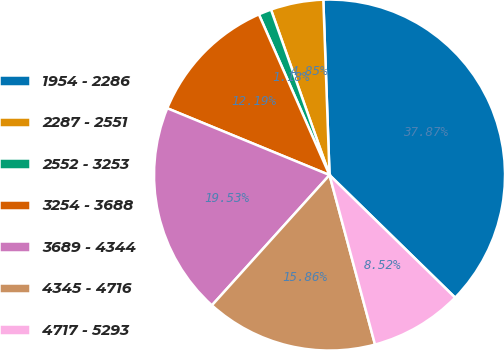<chart> <loc_0><loc_0><loc_500><loc_500><pie_chart><fcel>1954 - 2286<fcel>2287 - 2551<fcel>2552 - 3253<fcel>3254 - 3688<fcel>3689 - 4344<fcel>4345 - 4716<fcel>4717 - 5293<nl><fcel>37.87%<fcel>4.85%<fcel>1.18%<fcel>12.19%<fcel>19.53%<fcel>15.86%<fcel>8.52%<nl></chart> 